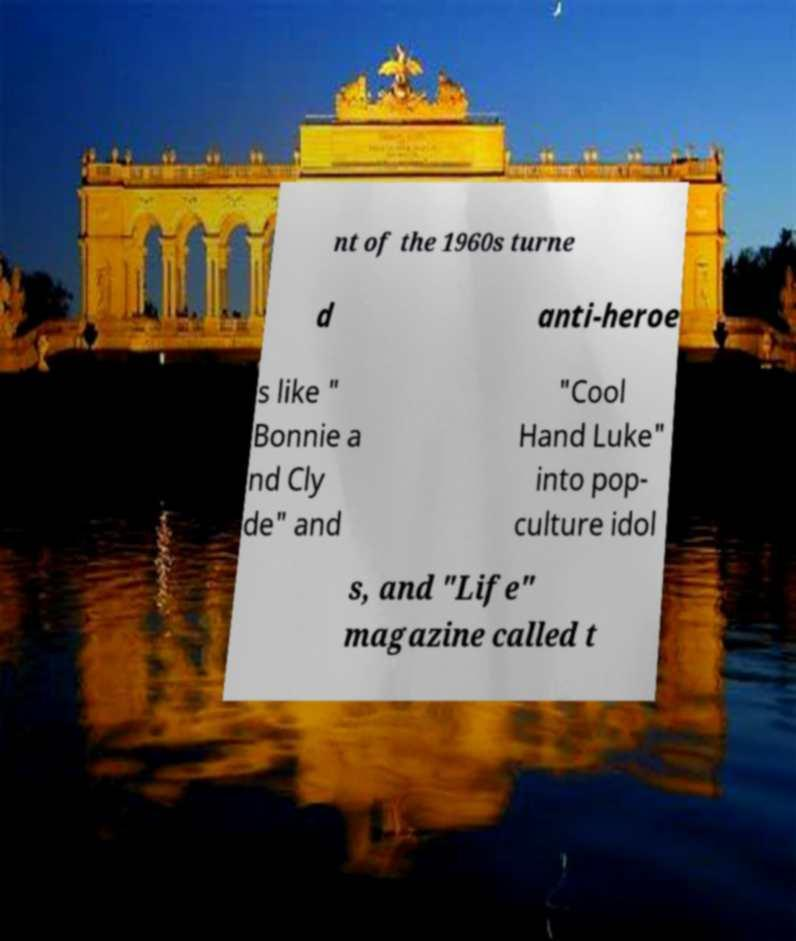What messages or text are displayed in this image? I need them in a readable, typed format. nt of the 1960s turne d anti-heroe s like " Bonnie a nd Cly de" and "Cool Hand Luke" into pop- culture idol s, and "Life" magazine called t 